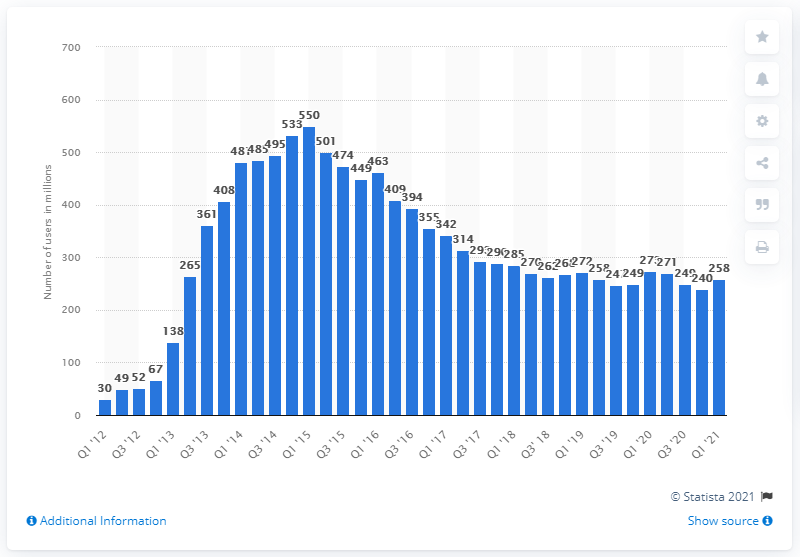Give some essential details in this illustration. In the first quarter of 2021, King's apps were accessed by an average of 258 people per month. 